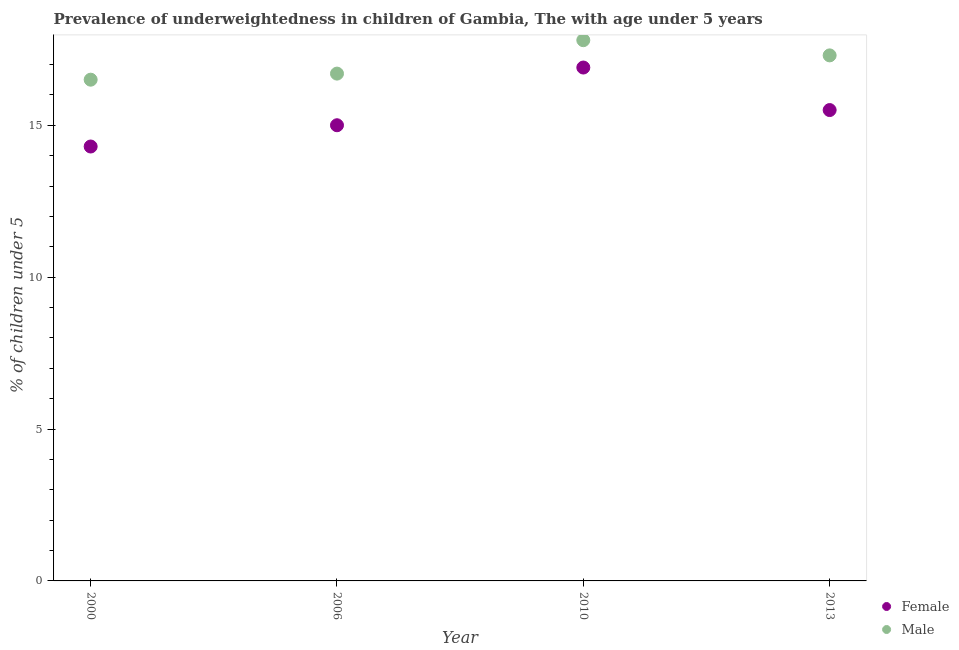What is the percentage of underweighted male children in 2010?
Offer a terse response. 17.8. Across all years, what is the maximum percentage of underweighted male children?
Give a very brief answer. 17.8. Across all years, what is the minimum percentage of underweighted male children?
Ensure brevity in your answer.  16.5. In which year was the percentage of underweighted female children minimum?
Offer a terse response. 2000. What is the total percentage of underweighted male children in the graph?
Give a very brief answer. 68.3. What is the difference between the percentage of underweighted female children in 2000 and that in 2013?
Your answer should be very brief. -1.2. What is the difference between the percentage of underweighted female children in 2010 and the percentage of underweighted male children in 2006?
Ensure brevity in your answer.  0.2. What is the average percentage of underweighted male children per year?
Make the answer very short. 17.07. In the year 2013, what is the difference between the percentage of underweighted female children and percentage of underweighted male children?
Ensure brevity in your answer.  -1.8. In how many years, is the percentage of underweighted male children greater than 7 %?
Make the answer very short. 4. What is the ratio of the percentage of underweighted female children in 2000 to that in 2010?
Keep it short and to the point. 0.85. Is the difference between the percentage of underweighted male children in 2006 and 2010 greater than the difference between the percentage of underweighted female children in 2006 and 2010?
Offer a terse response. Yes. What is the difference between the highest and the second highest percentage of underweighted female children?
Offer a terse response. 1.4. What is the difference between the highest and the lowest percentage of underweighted male children?
Your response must be concise. 1.3. In how many years, is the percentage of underweighted male children greater than the average percentage of underweighted male children taken over all years?
Keep it short and to the point. 2. Is the percentage of underweighted female children strictly less than the percentage of underweighted male children over the years?
Your answer should be compact. Yes. How many dotlines are there?
Offer a terse response. 2. Are the values on the major ticks of Y-axis written in scientific E-notation?
Keep it short and to the point. No. Does the graph contain any zero values?
Give a very brief answer. No. Does the graph contain grids?
Offer a very short reply. No. Where does the legend appear in the graph?
Make the answer very short. Bottom right. What is the title of the graph?
Keep it short and to the point. Prevalence of underweightedness in children of Gambia, The with age under 5 years. Does "Official aid received" appear as one of the legend labels in the graph?
Your response must be concise. No. What is the label or title of the Y-axis?
Your answer should be compact.  % of children under 5. What is the  % of children under 5 in Female in 2000?
Give a very brief answer. 14.3. What is the  % of children under 5 of Male in 2000?
Make the answer very short. 16.5. What is the  % of children under 5 in Male in 2006?
Keep it short and to the point. 16.7. What is the  % of children under 5 in Female in 2010?
Ensure brevity in your answer.  16.9. What is the  % of children under 5 of Male in 2010?
Your response must be concise. 17.8. What is the  % of children under 5 in Male in 2013?
Your answer should be very brief. 17.3. Across all years, what is the maximum  % of children under 5 in Female?
Your answer should be compact. 16.9. Across all years, what is the maximum  % of children under 5 in Male?
Ensure brevity in your answer.  17.8. Across all years, what is the minimum  % of children under 5 in Female?
Offer a terse response. 14.3. Across all years, what is the minimum  % of children under 5 in Male?
Provide a short and direct response. 16.5. What is the total  % of children under 5 of Female in the graph?
Your response must be concise. 61.7. What is the total  % of children under 5 in Male in the graph?
Ensure brevity in your answer.  68.3. What is the difference between the  % of children under 5 of Female in 2000 and that in 2010?
Your answer should be compact. -2.6. What is the difference between the  % of children under 5 in Female in 2000 and that in 2013?
Keep it short and to the point. -1.2. What is the difference between the  % of children under 5 of Male in 2000 and that in 2013?
Your answer should be very brief. -0.8. What is the difference between the  % of children under 5 in Male in 2006 and that in 2010?
Ensure brevity in your answer.  -1.1. What is the difference between the  % of children under 5 of Male in 2006 and that in 2013?
Ensure brevity in your answer.  -0.6. What is the difference between the  % of children under 5 in Female in 2000 and the  % of children under 5 in Male in 2006?
Provide a short and direct response. -2.4. What is the difference between the  % of children under 5 in Female in 2000 and the  % of children under 5 in Male in 2010?
Offer a very short reply. -3.5. What is the difference between the  % of children under 5 of Female in 2000 and the  % of children under 5 of Male in 2013?
Your answer should be very brief. -3. What is the difference between the  % of children under 5 of Female in 2006 and the  % of children under 5 of Male in 2013?
Offer a terse response. -2.3. What is the difference between the  % of children under 5 of Female in 2010 and the  % of children under 5 of Male in 2013?
Your answer should be compact. -0.4. What is the average  % of children under 5 of Female per year?
Your answer should be very brief. 15.43. What is the average  % of children under 5 in Male per year?
Ensure brevity in your answer.  17.07. In the year 2010, what is the difference between the  % of children under 5 in Female and  % of children under 5 in Male?
Give a very brief answer. -0.9. In the year 2013, what is the difference between the  % of children under 5 in Female and  % of children under 5 in Male?
Your answer should be compact. -1.8. What is the ratio of the  % of children under 5 in Female in 2000 to that in 2006?
Your answer should be compact. 0.95. What is the ratio of the  % of children under 5 of Male in 2000 to that in 2006?
Ensure brevity in your answer.  0.99. What is the ratio of the  % of children under 5 in Female in 2000 to that in 2010?
Offer a very short reply. 0.85. What is the ratio of the  % of children under 5 of Male in 2000 to that in 2010?
Your answer should be compact. 0.93. What is the ratio of the  % of children under 5 of Female in 2000 to that in 2013?
Provide a succinct answer. 0.92. What is the ratio of the  % of children under 5 in Male in 2000 to that in 2013?
Make the answer very short. 0.95. What is the ratio of the  % of children under 5 of Female in 2006 to that in 2010?
Your answer should be compact. 0.89. What is the ratio of the  % of children under 5 in Male in 2006 to that in 2010?
Provide a short and direct response. 0.94. What is the ratio of the  % of children under 5 in Male in 2006 to that in 2013?
Ensure brevity in your answer.  0.97. What is the ratio of the  % of children under 5 of Female in 2010 to that in 2013?
Your response must be concise. 1.09. What is the ratio of the  % of children under 5 in Male in 2010 to that in 2013?
Ensure brevity in your answer.  1.03. 